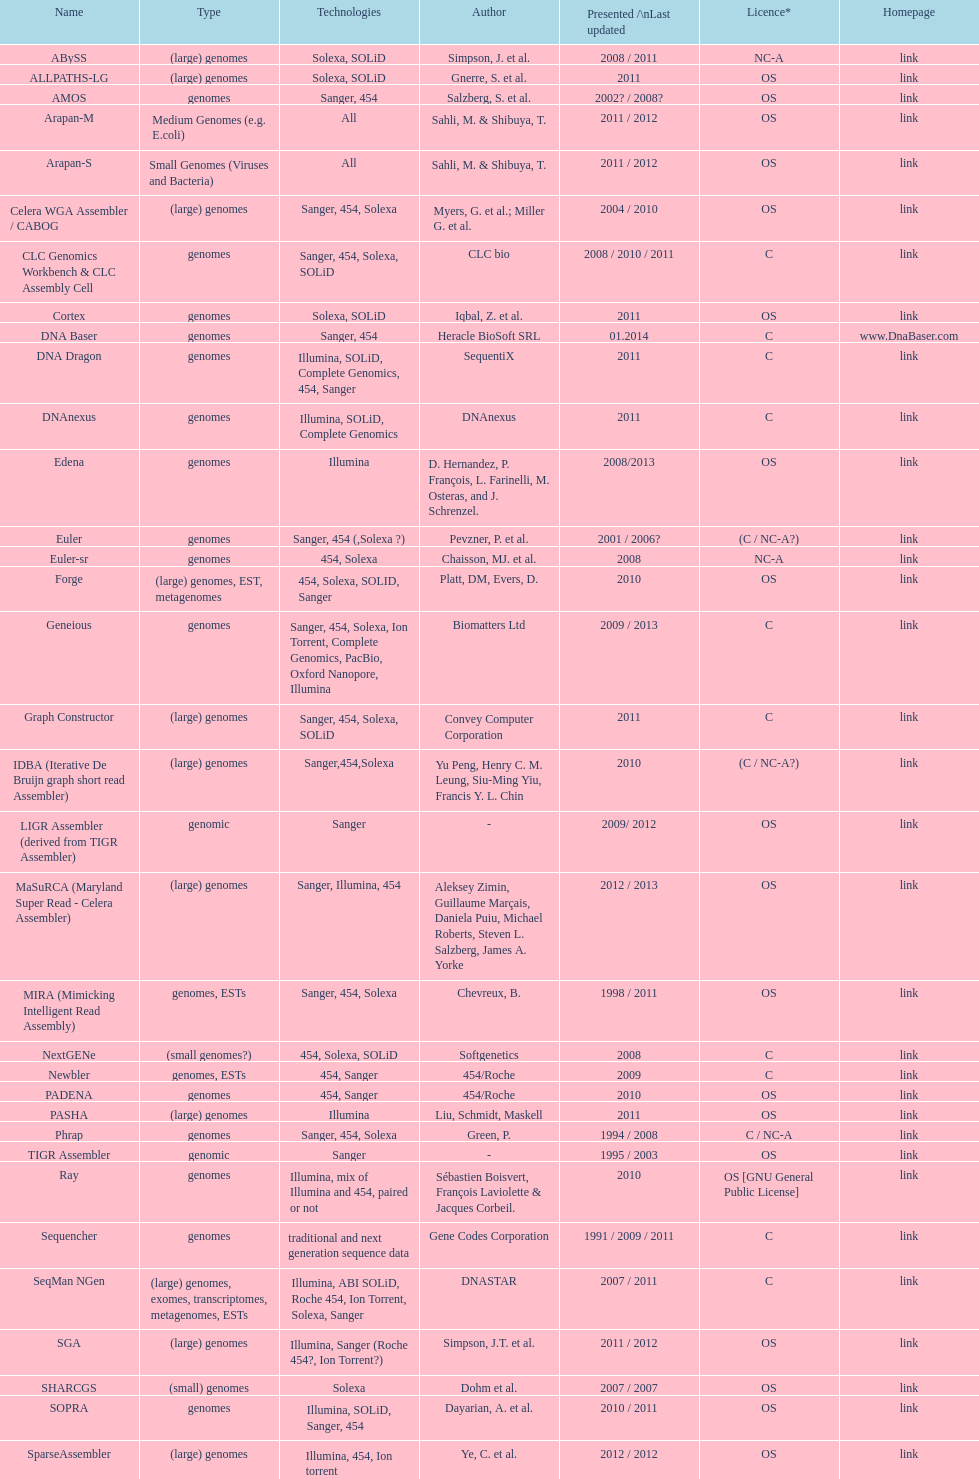What was the total number of times sahi, m. & shilbuya, t. listed as co-authors? 2. Would you be able to parse every entry in this table? {'header': ['Name', 'Type', 'Technologies', 'Author', 'Presented /\\nLast updated', 'Licence*', 'Homepage'], 'rows': [['ABySS', '(large) genomes', 'Solexa, SOLiD', 'Simpson, J. et al.', '2008 / 2011', 'NC-A', 'link'], ['ALLPATHS-LG', '(large) genomes', 'Solexa, SOLiD', 'Gnerre, S. et al.', '2011', 'OS', 'link'], ['AMOS', 'genomes', 'Sanger, 454', 'Salzberg, S. et al.', '2002? / 2008?', 'OS', 'link'], ['Arapan-M', 'Medium Genomes (e.g. E.coli)', 'All', 'Sahli, M. & Shibuya, T.', '2011 / 2012', 'OS', 'link'], ['Arapan-S', 'Small Genomes (Viruses and Bacteria)', 'All', 'Sahli, M. & Shibuya, T.', '2011 / 2012', 'OS', 'link'], ['Celera WGA Assembler / CABOG', '(large) genomes', 'Sanger, 454, Solexa', 'Myers, G. et al.; Miller G. et al.', '2004 / 2010', 'OS', 'link'], ['CLC Genomics Workbench & CLC Assembly Cell', 'genomes', 'Sanger, 454, Solexa, SOLiD', 'CLC bio', '2008 / 2010 / 2011', 'C', 'link'], ['Cortex', 'genomes', 'Solexa, SOLiD', 'Iqbal, Z. et al.', '2011', 'OS', 'link'], ['DNA Baser', 'genomes', 'Sanger, 454', 'Heracle BioSoft SRL', '01.2014', 'C', 'www.DnaBaser.com'], ['DNA Dragon', 'genomes', 'Illumina, SOLiD, Complete Genomics, 454, Sanger', 'SequentiX', '2011', 'C', 'link'], ['DNAnexus', 'genomes', 'Illumina, SOLiD, Complete Genomics', 'DNAnexus', '2011', 'C', 'link'], ['Edena', 'genomes', 'Illumina', 'D. Hernandez, P. François, L. Farinelli, M. Osteras, and J. Schrenzel.', '2008/2013', 'OS', 'link'], ['Euler', 'genomes', 'Sanger, 454 (,Solexa\xa0?)', 'Pevzner, P. et al.', '2001 / 2006?', '(C / NC-A?)', 'link'], ['Euler-sr', 'genomes', '454, Solexa', 'Chaisson, MJ. et al.', '2008', 'NC-A', 'link'], ['Forge', '(large) genomes, EST, metagenomes', '454, Solexa, SOLID, Sanger', 'Platt, DM, Evers, D.', '2010', 'OS', 'link'], ['Geneious', 'genomes', 'Sanger, 454, Solexa, Ion Torrent, Complete Genomics, PacBio, Oxford Nanopore, Illumina', 'Biomatters Ltd', '2009 / 2013', 'C', 'link'], ['Graph Constructor', '(large) genomes', 'Sanger, 454, Solexa, SOLiD', 'Convey Computer Corporation', '2011', 'C', 'link'], ['IDBA (Iterative De Bruijn graph short read Assembler)', '(large) genomes', 'Sanger,454,Solexa', 'Yu Peng, Henry C. M. Leung, Siu-Ming Yiu, Francis Y. L. Chin', '2010', '(C / NC-A?)', 'link'], ['LIGR Assembler (derived from TIGR Assembler)', 'genomic', 'Sanger', '-', '2009/ 2012', 'OS', 'link'], ['MaSuRCA (Maryland Super Read - Celera Assembler)', '(large) genomes', 'Sanger, Illumina, 454', 'Aleksey Zimin, Guillaume Marçais, Daniela Puiu, Michael Roberts, Steven L. Salzberg, James A. Yorke', '2012 / 2013', 'OS', 'link'], ['MIRA (Mimicking Intelligent Read Assembly)', 'genomes, ESTs', 'Sanger, 454, Solexa', 'Chevreux, B.', '1998 / 2011', 'OS', 'link'], ['NextGENe', '(small genomes?)', '454, Solexa, SOLiD', 'Softgenetics', '2008', 'C', 'link'], ['Newbler', 'genomes, ESTs', '454, Sanger', '454/Roche', '2009', 'C', 'link'], ['PADENA', 'genomes', '454, Sanger', '454/Roche', '2010', 'OS', 'link'], ['PASHA', '(large) genomes', 'Illumina', 'Liu, Schmidt, Maskell', '2011', 'OS', 'link'], ['Phrap', 'genomes', 'Sanger, 454, Solexa', 'Green, P.', '1994 / 2008', 'C / NC-A', 'link'], ['TIGR Assembler', 'genomic', 'Sanger', '-', '1995 / 2003', 'OS', 'link'], ['Ray', 'genomes', 'Illumina, mix of Illumina and 454, paired or not', 'Sébastien Boisvert, François Laviolette & Jacques Corbeil.', '2010', 'OS [GNU General Public License]', 'link'], ['Sequencher', 'genomes', 'traditional and next generation sequence data', 'Gene Codes Corporation', '1991 / 2009 / 2011', 'C', 'link'], ['SeqMan NGen', '(large) genomes, exomes, transcriptomes, metagenomes, ESTs', 'Illumina, ABI SOLiD, Roche 454, Ion Torrent, Solexa, Sanger', 'DNASTAR', '2007 / 2011', 'C', 'link'], ['SGA', '(large) genomes', 'Illumina, Sanger (Roche 454?, Ion Torrent?)', 'Simpson, J.T. et al.', '2011 / 2012', 'OS', 'link'], ['SHARCGS', '(small) genomes', 'Solexa', 'Dohm et al.', '2007 / 2007', 'OS', 'link'], ['SOPRA', 'genomes', 'Illumina, SOLiD, Sanger, 454', 'Dayarian, A. et al.', '2010 / 2011', 'OS', 'link'], ['SparseAssembler', '(large) genomes', 'Illumina, 454, Ion torrent', 'Ye, C. et al.', '2012 / 2012', 'OS', 'link'], ['SSAKE', '(small) genomes', 'Solexa (SOLiD? Helicos?)', 'Warren, R. et al.', '2007 / 2007', 'OS', 'link'], ['SOAPdenovo', 'genomes', 'Solexa', 'Li, R. et al.', '2009 / 2009', 'OS', 'link'], ['SPAdes', '(small) genomes, single-cell', 'Illumina, Solexa', 'Bankevich, A et al.', '2012 / 2013', 'OS', 'link'], ['Staden gap4 package', 'BACs (, small genomes?)', 'Sanger', 'Staden et al.', '1991 / 2008', 'OS', 'link'], ['Taipan', '(small) genomes', 'Illumina', 'Schmidt, B. et al.', '2009', 'OS', 'link'], ['VCAKE', '(small) genomes', 'Solexa (SOLiD?, Helicos?)', 'Jeck, W. et al.', '2007 / 2007', 'OS', 'link'], ['Phusion assembler', '(large) genomes', 'Sanger', 'Mullikin JC, et al.', '2003', 'OS', 'link'], ['Quality Value Guided SRA (QSRA)', 'genomes', 'Sanger, Solexa', 'Bryant DW, et al.', '2009', 'OS', 'link'], ['Velvet', '(small) genomes', 'Sanger, 454, Solexa, SOLiD', 'Zerbino, D. et al.', '2007 / 2009', 'OS', 'link']]} 